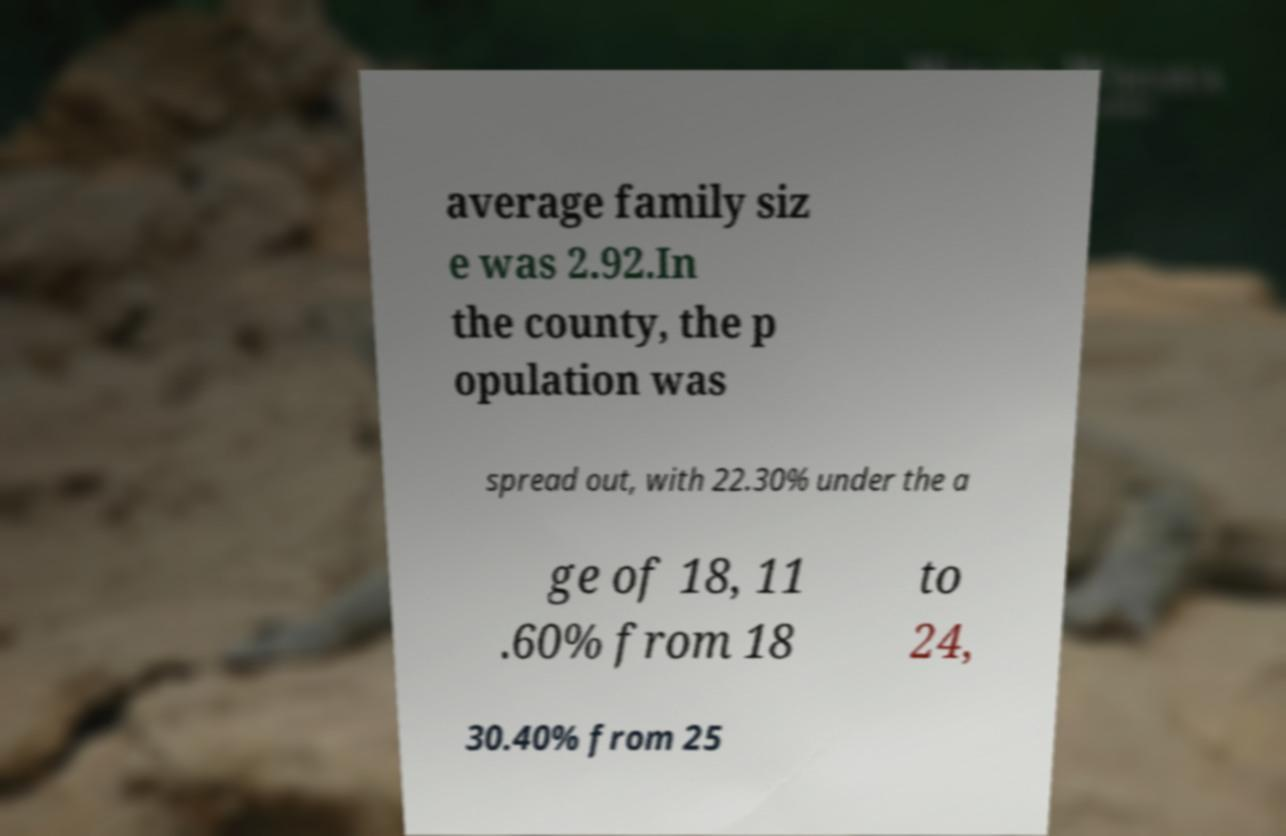Please identify and transcribe the text found in this image. average family siz e was 2.92.In the county, the p opulation was spread out, with 22.30% under the a ge of 18, 11 .60% from 18 to 24, 30.40% from 25 